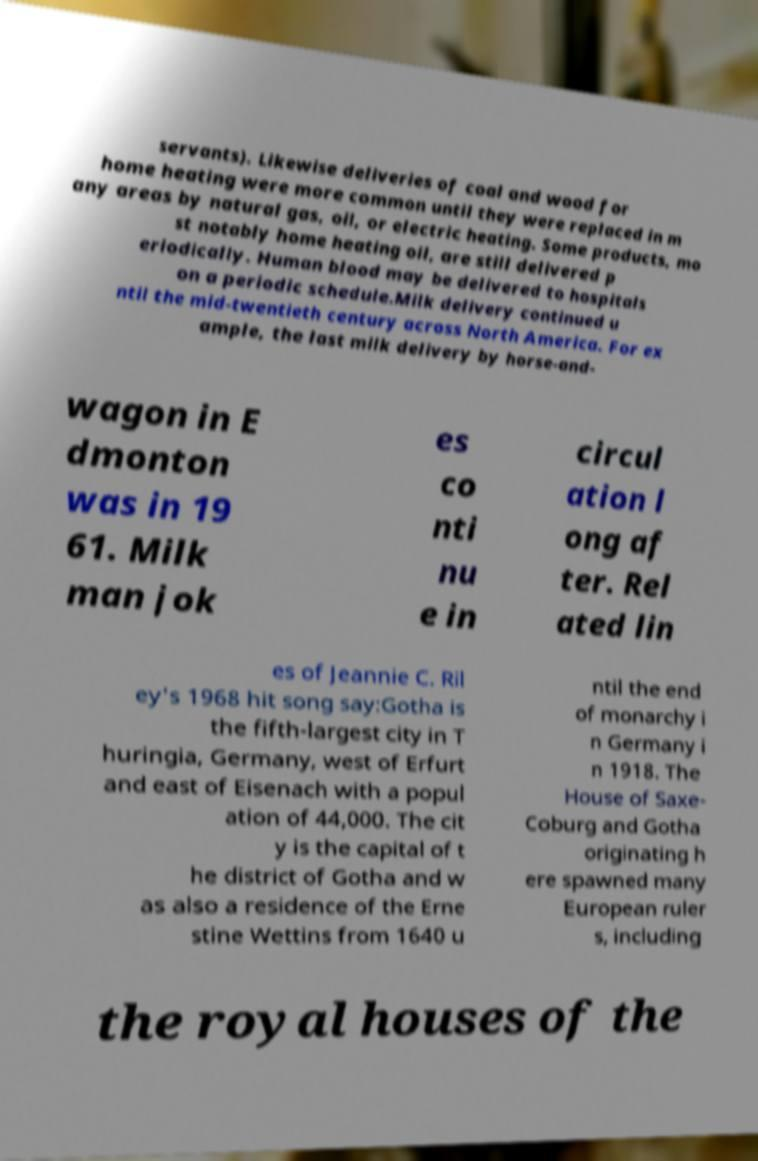For documentation purposes, I need the text within this image transcribed. Could you provide that? servants). Likewise deliveries of coal and wood for home heating were more common until they were replaced in m any areas by natural gas, oil, or electric heating. Some products, mo st notably home heating oil, are still delivered p eriodically. Human blood may be delivered to hospitals on a periodic schedule.Milk delivery continued u ntil the mid-twentieth century across North America. For ex ample, the last milk delivery by horse-and- wagon in E dmonton was in 19 61. Milk man jok es co nti nu e in circul ation l ong af ter. Rel ated lin es of Jeannie C. Ril ey's 1968 hit song say:Gotha is the fifth-largest city in T huringia, Germany, west of Erfurt and east of Eisenach with a popul ation of 44,000. The cit y is the capital of t he district of Gotha and w as also a residence of the Erne stine Wettins from 1640 u ntil the end of monarchy i n Germany i n 1918. The House of Saxe- Coburg and Gotha originating h ere spawned many European ruler s, including the royal houses of the 